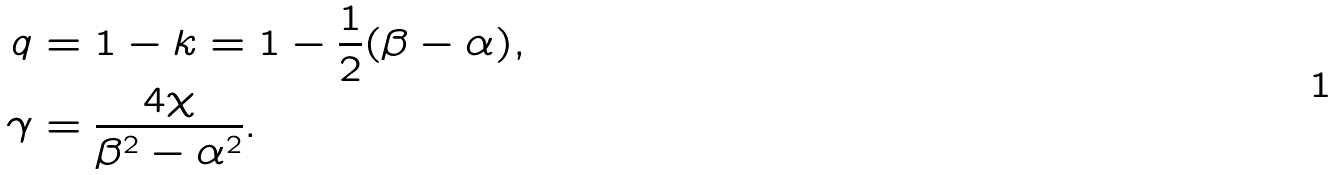<formula> <loc_0><loc_0><loc_500><loc_500>q & = 1 - k = 1 - \frac { 1 } { 2 } ( \beta - \alpha ) , \\ \gamma & = \frac { 4 \chi } { \beta ^ { 2 } - \alpha ^ { 2 } } .</formula> 